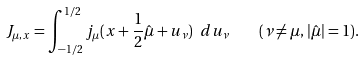<formula> <loc_0><loc_0><loc_500><loc_500>J _ { \mu , x } = \int _ { - 1 / 2 } ^ { 1 / 2 } j _ { \mu } ( x + \frac { 1 } { 2 } \hat { \mu } + u _ { \nu } ) \ d u _ { \nu } \quad ( \nu \neq \mu , | \hat { \mu } | = 1 ) .</formula> 